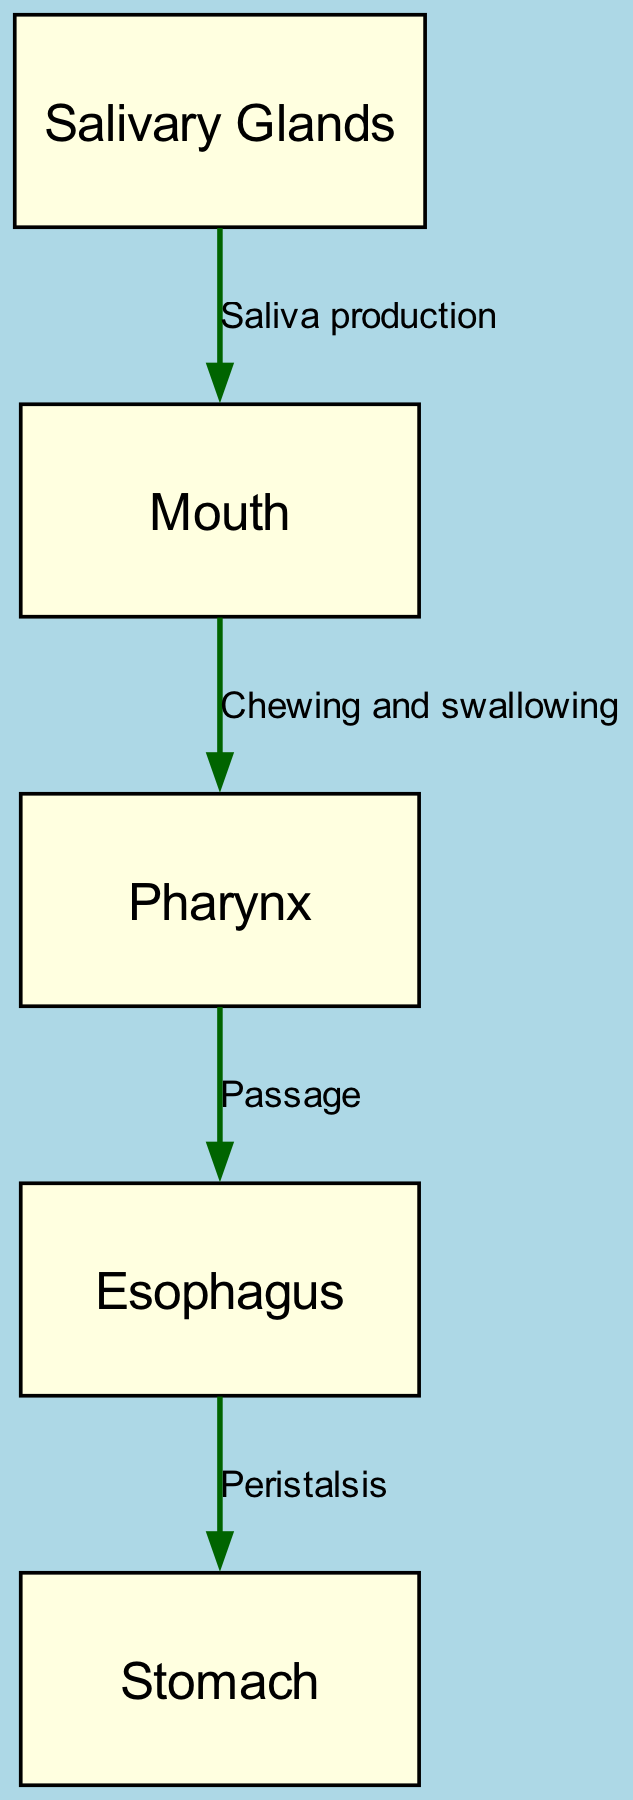What is the first node in the digestive pathway? The first node represents where the digestive process begins, which is the "Mouth." This is indicated as the starting point in the diagram.
Answer: Mouth How many nodes are in the diagram? To find the total number of nodes, I will count each unique point that represents a part of the digestive system in the diagram. There are five nodes: Mouth, Esophagus, Stomach, Salivary Glands, and Pharynx.
Answer: 5 What does the edge from "Mouth" to "Pharynx" represent? The edge connects the "Mouth" to "Pharynx" and is labeled with "Chewing and swallowing," which describes the action involved in moving food from the mouth to the pharynx.
Answer: Chewing and swallowing Which node produces saliva? The node labeled "Salivary Glands" indicates the part of the body responsible for the production of saliva, which is essential for digestion.
Answer: Salivary Glands What action is described by the edge connecting "Esophagus" to "Stomach"? The edge between these two nodes is labeled "Peristalsis," which refers to the wave-like muscle contractions that move food along the digestive tract from the esophagus into the stomach.
Answer: Peristalsis What is the passage between "Pharynx" and "Esophagus" called? The connection between "Pharynx" and "Esophagus" is labeled as "Passage." This indicates that it serves as a pathway for food to move from the pharynx into the esophagus.
Answer: Passage Which two nodes are linked by the action of saliva production? The "Salivary Glands" node is linked to the "Mouth" node, indicating that saliva production occurs in the salivary glands before it enters the mouth for digestion.
Answer: Salivary Glands and Mouth What is the direction of flow from "Esophagus" to "Stomach"? The flow direction is shown by the arrow pointing from "Esophagus" to "Stomach," representing the movement of food under the influence of peristalsis.
Answer: Esophagus to Stomach How many edges connect the nodes in this diagram? I can count the lines (edges) that connect the nodes in the diagram. There are four edges: Mouth to Pharynx, Pharynx to Esophagus, Esophagus to Stomach, and Salivary Glands to Mouth.
Answer: 4 